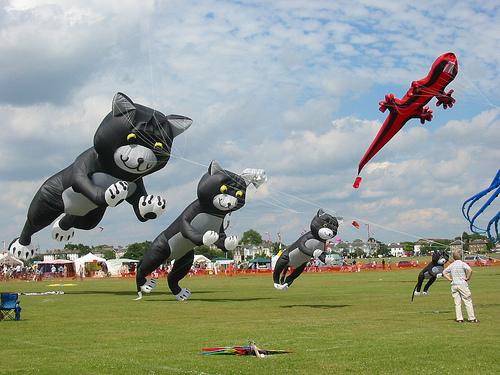What type of animal is the red balloon?
Answer briefly. Lizard. What color is the person on the right wearing?
Write a very short answer. White. How many cat balloons are there?
Write a very short answer. 4. 